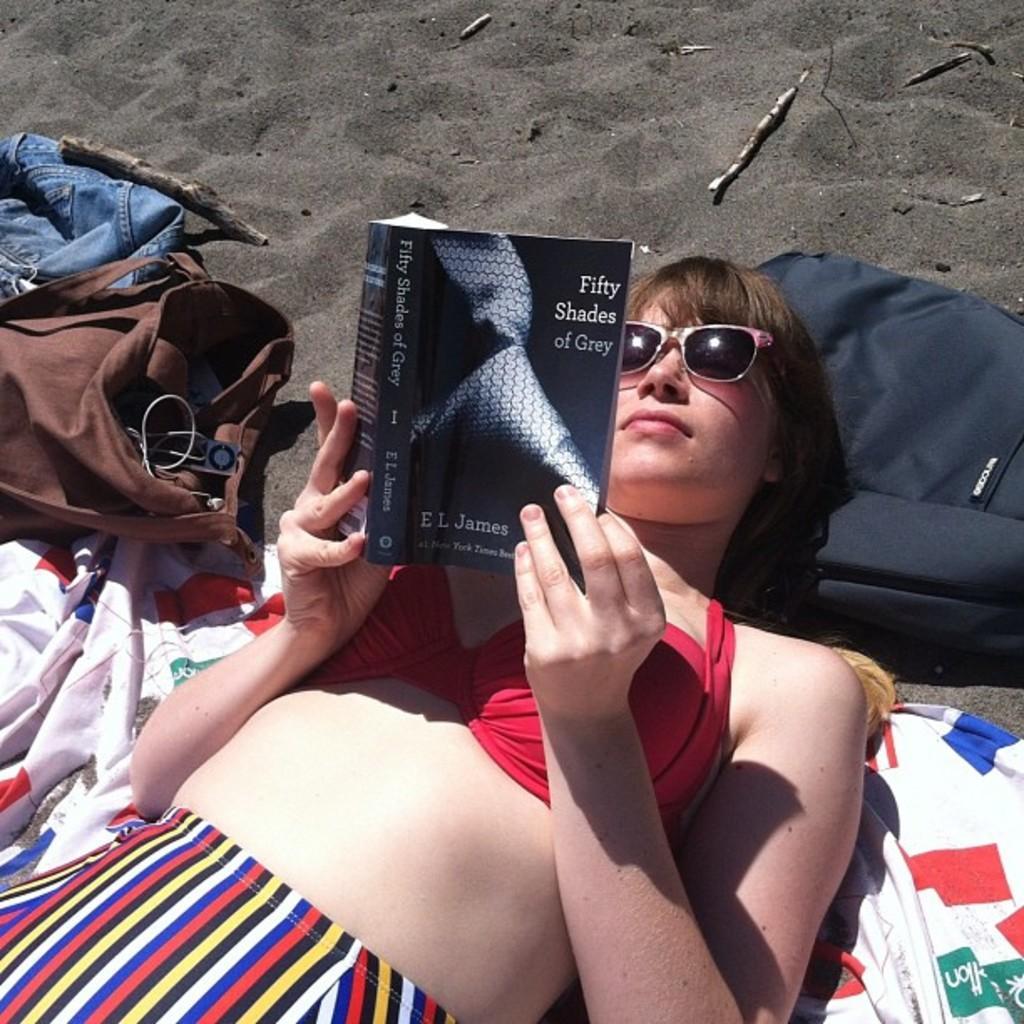Could you give a brief overview of what you see in this image? In this picture there is a woman lying and holding the book and there is text on the book. At the bottom there are bags and there are clothes on the sand. 